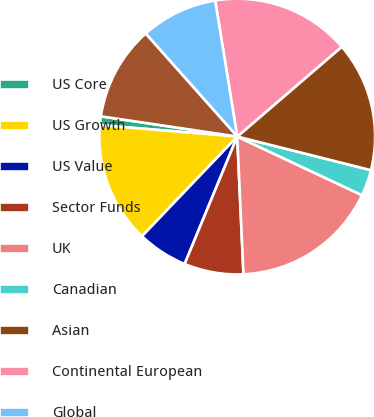Convert chart to OTSL. <chart><loc_0><loc_0><loc_500><loc_500><pie_chart><fcel>US Core<fcel>US Growth<fcel>US Value<fcel>Sector Funds<fcel>UK<fcel>Canadian<fcel>Asian<fcel>Continental European<fcel>Global<fcel>Global Ex US and Emerging<nl><fcel>1.02%<fcel>14.19%<fcel>5.91%<fcel>6.95%<fcel>17.29%<fcel>3.07%<fcel>15.22%<fcel>16.26%<fcel>9.01%<fcel>11.08%<nl></chart> 